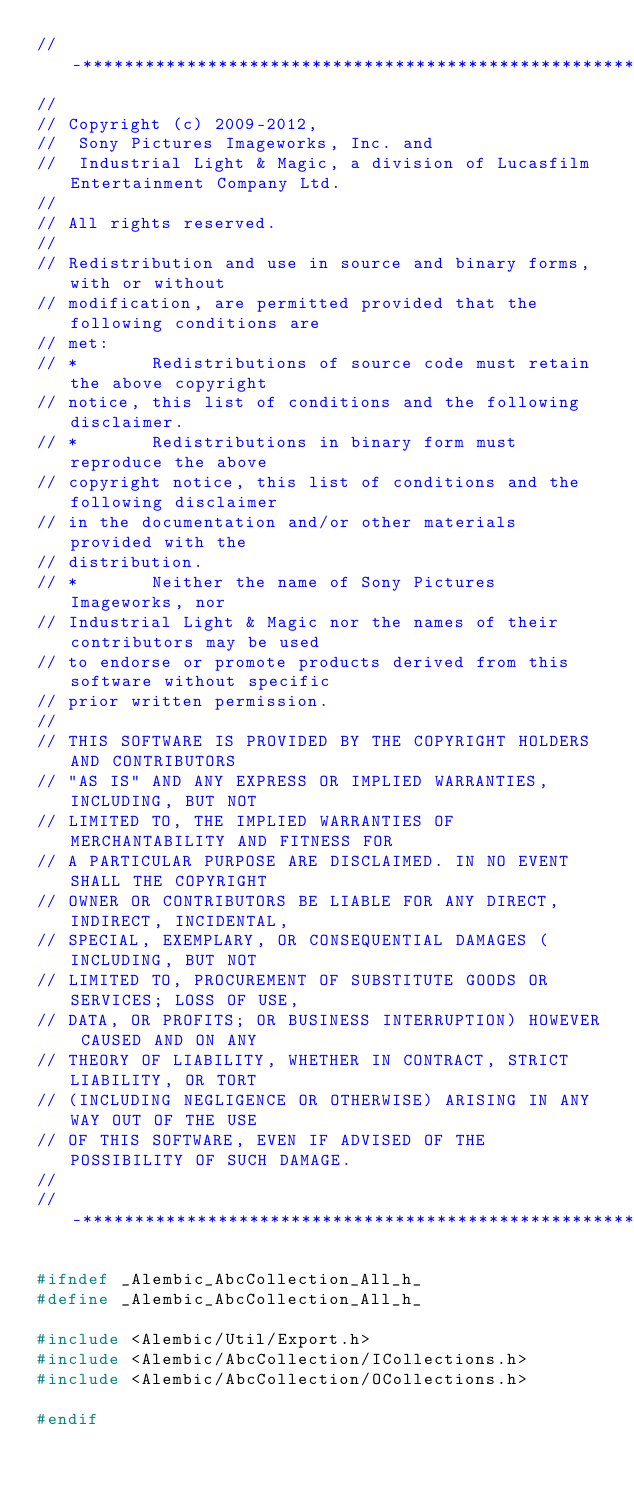Convert code to text. <code><loc_0><loc_0><loc_500><loc_500><_C_>//-*****************************************************************************
//
// Copyright (c) 2009-2012,
//  Sony Pictures Imageworks, Inc. and
//  Industrial Light & Magic, a division of Lucasfilm Entertainment Company Ltd.
//
// All rights reserved.
//
// Redistribution and use in source and binary forms, with or without
// modification, are permitted provided that the following conditions are
// met:
// *       Redistributions of source code must retain the above copyright
// notice, this list of conditions and the following disclaimer.
// *       Redistributions in binary form must reproduce the above
// copyright notice, this list of conditions and the following disclaimer
// in the documentation and/or other materials provided with the
// distribution.
// *       Neither the name of Sony Pictures Imageworks, nor
// Industrial Light & Magic nor the names of their contributors may be used
// to endorse or promote products derived from this software without specific
// prior written permission.
//
// THIS SOFTWARE IS PROVIDED BY THE COPYRIGHT HOLDERS AND CONTRIBUTORS
// "AS IS" AND ANY EXPRESS OR IMPLIED WARRANTIES, INCLUDING, BUT NOT
// LIMITED TO, THE IMPLIED WARRANTIES OF MERCHANTABILITY AND FITNESS FOR
// A PARTICULAR PURPOSE ARE DISCLAIMED. IN NO EVENT SHALL THE COPYRIGHT
// OWNER OR CONTRIBUTORS BE LIABLE FOR ANY DIRECT, INDIRECT, INCIDENTAL,
// SPECIAL, EXEMPLARY, OR CONSEQUENTIAL DAMAGES (INCLUDING, BUT NOT
// LIMITED TO, PROCUREMENT OF SUBSTITUTE GOODS OR SERVICES; LOSS OF USE,
// DATA, OR PROFITS; OR BUSINESS INTERRUPTION) HOWEVER CAUSED AND ON ANY
// THEORY OF LIABILITY, WHETHER IN CONTRACT, STRICT LIABILITY, OR TORT
// (INCLUDING NEGLIGENCE OR OTHERWISE) ARISING IN ANY WAY OUT OF THE USE
// OF THIS SOFTWARE, EVEN IF ADVISED OF THE POSSIBILITY OF SUCH DAMAGE.
//
//-*****************************************************************************

#ifndef _Alembic_AbcCollection_All_h_
#define _Alembic_AbcCollection_All_h_

#include <Alembic/Util/Export.h>
#include <Alembic/AbcCollection/ICollections.h>
#include <Alembic/AbcCollection/OCollections.h>

#endif
</code> 